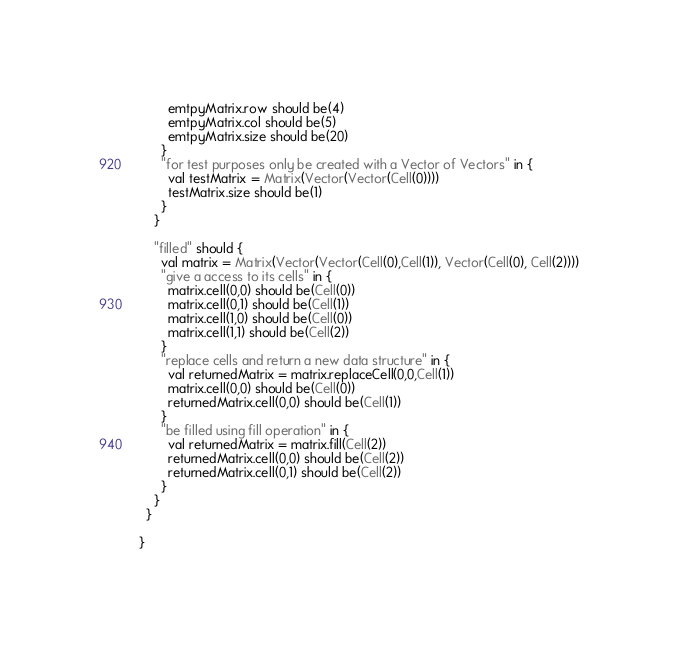Convert code to text. <code><loc_0><loc_0><loc_500><loc_500><_Scala_>        emtpyMatrix.row should be(4)
        emtpyMatrix.col should be(5)
        emtpyMatrix.size should be(20)
      }
      "for test purposes only be created with a Vector of Vectors" in {
        val testMatrix = Matrix(Vector(Vector(Cell(0))))
        testMatrix.size should be(1)
      }
    }

    "filled" should {
      val matrix = Matrix(Vector(Vector(Cell(0),Cell(1)), Vector(Cell(0), Cell(2))))
      "give a access to its cells" in {
        matrix.cell(0,0) should be(Cell(0))
        matrix.cell(0,1) should be(Cell(1))
        matrix.cell(1,0) should be(Cell(0))
        matrix.cell(1,1) should be(Cell(2))
      }
      "replace cells and return a new data structure" in {
        val returnedMatrix = matrix.replaceCell(0,0,Cell(1))
        matrix.cell(0,0) should be(Cell(0))
        returnedMatrix.cell(0,0) should be(Cell(1))
      }
      "be filled using fill operation" in {
        val returnedMatrix = matrix.fill(Cell(2))
        returnedMatrix.cell(0,0) should be(Cell(2))
        returnedMatrix.cell(0,1) should be(Cell(2))
      }
    }
  }

}
</code> 